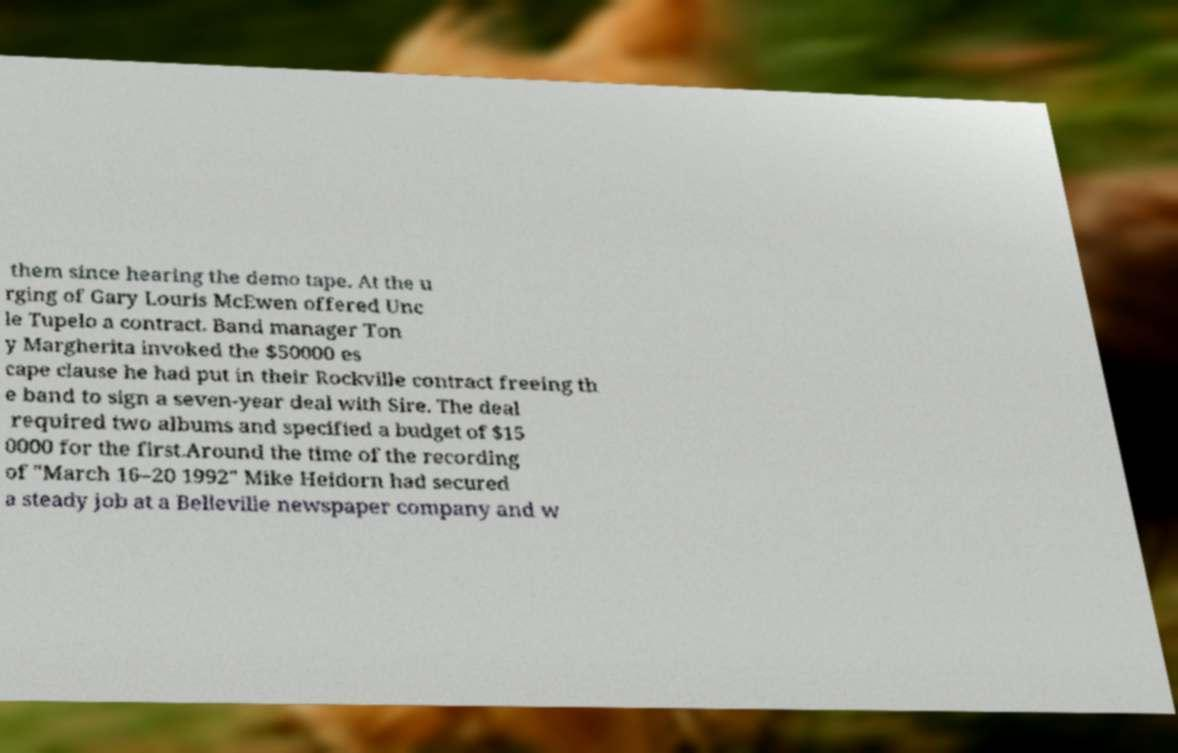For documentation purposes, I need the text within this image transcribed. Could you provide that? them since hearing the demo tape. At the u rging of Gary Louris McEwen offered Unc le Tupelo a contract. Band manager Ton y Margherita invoked the $50000 es cape clause he had put in their Rockville contract freeing th e band to sign a seven-year deal with Sire. The deal required two albums and specified a budget of $15 0000 for the first.Around the time of the recording of "March 16–20 1992" Mike Heidorn had secured a steady job at a Belleville newspaper company and w 